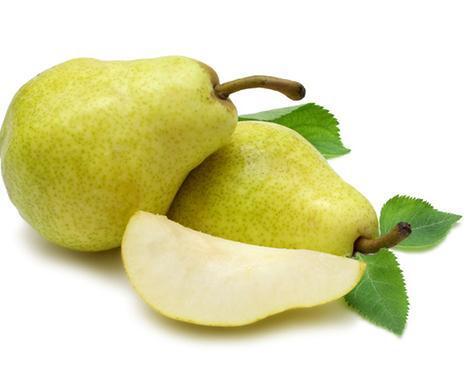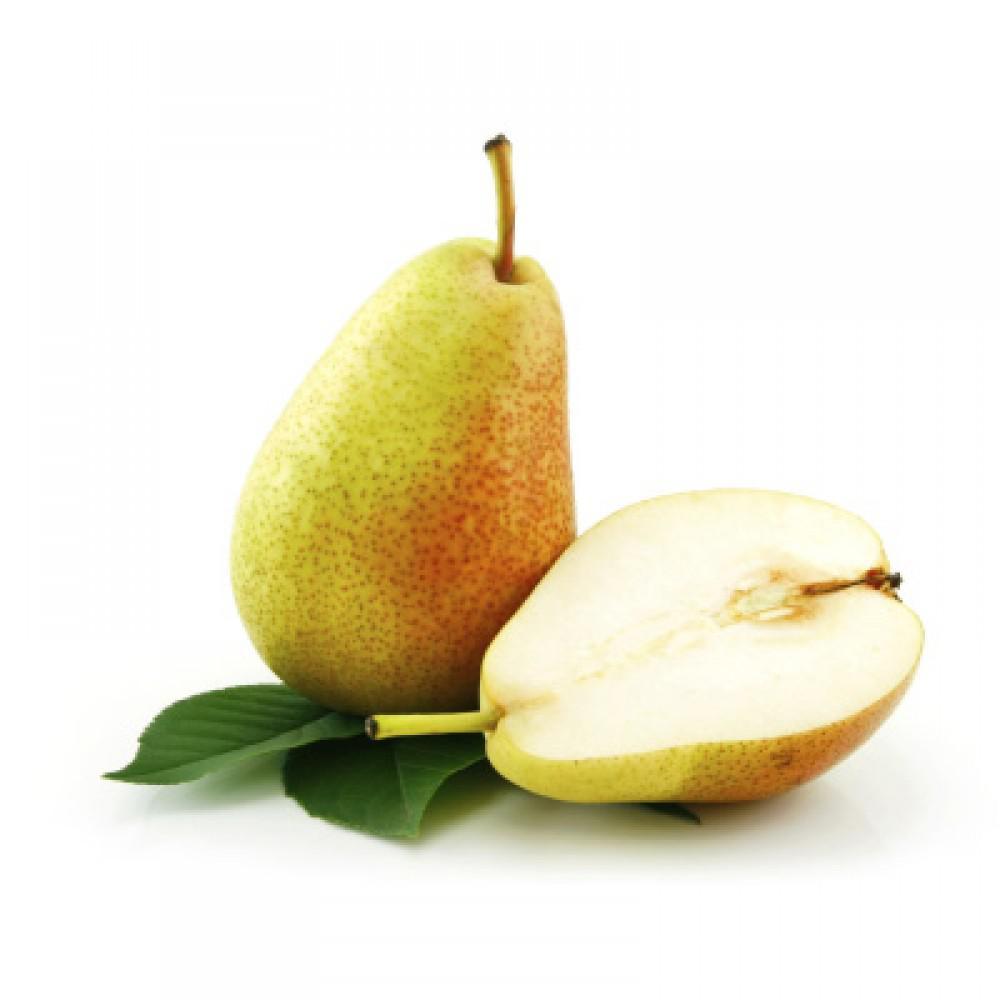The first image is the image on the left, the second image is the image on the right. For the images displayed, is the sentence "The left image includes at least one whole pear and a green leaf, and the right image contains at least three whole pears but no leaves." factually correct? Answer yes or no. No. The first image is the image on the left, the second image is the image on the right. Given the left and right images, does the statement "At least one of the images shows fruit hanging on a tree." hold true? Answer yes or no. No. 